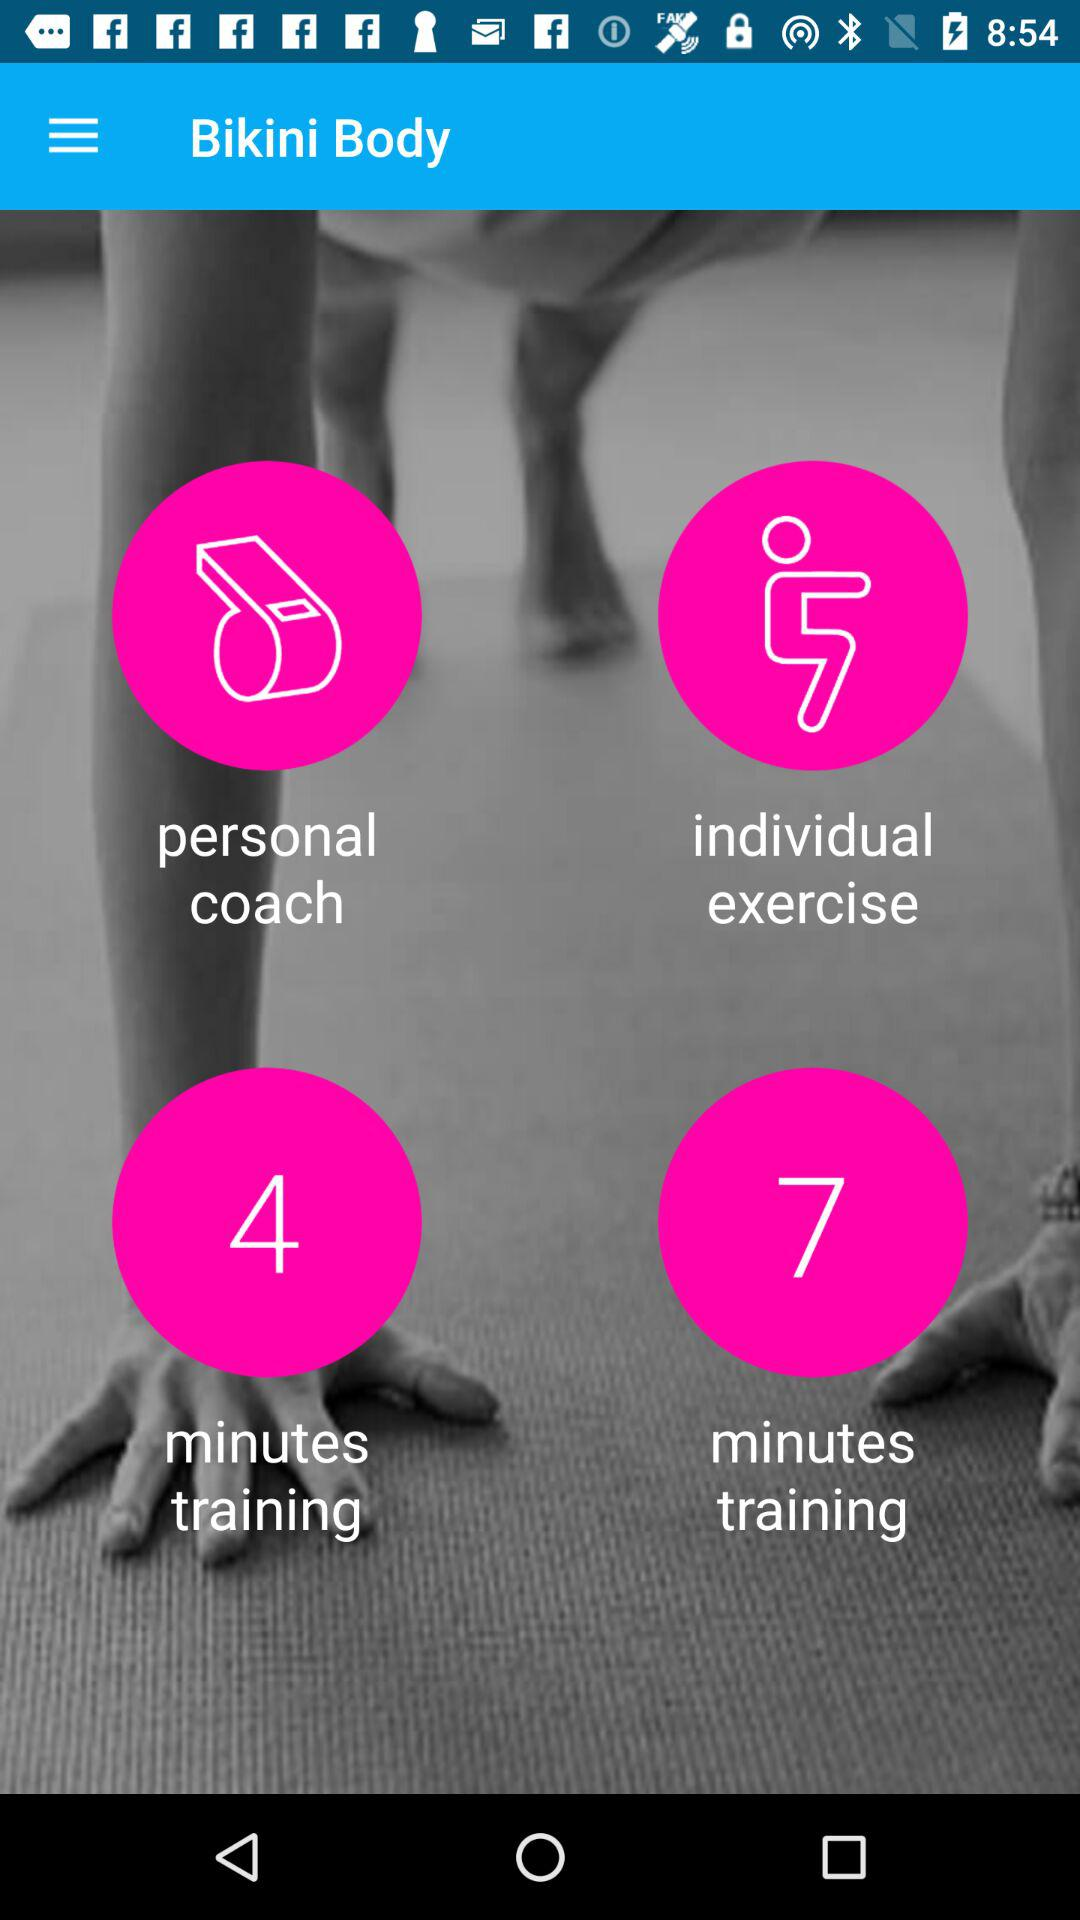What is the name of the application? The name of the application is "Bikini Body". 